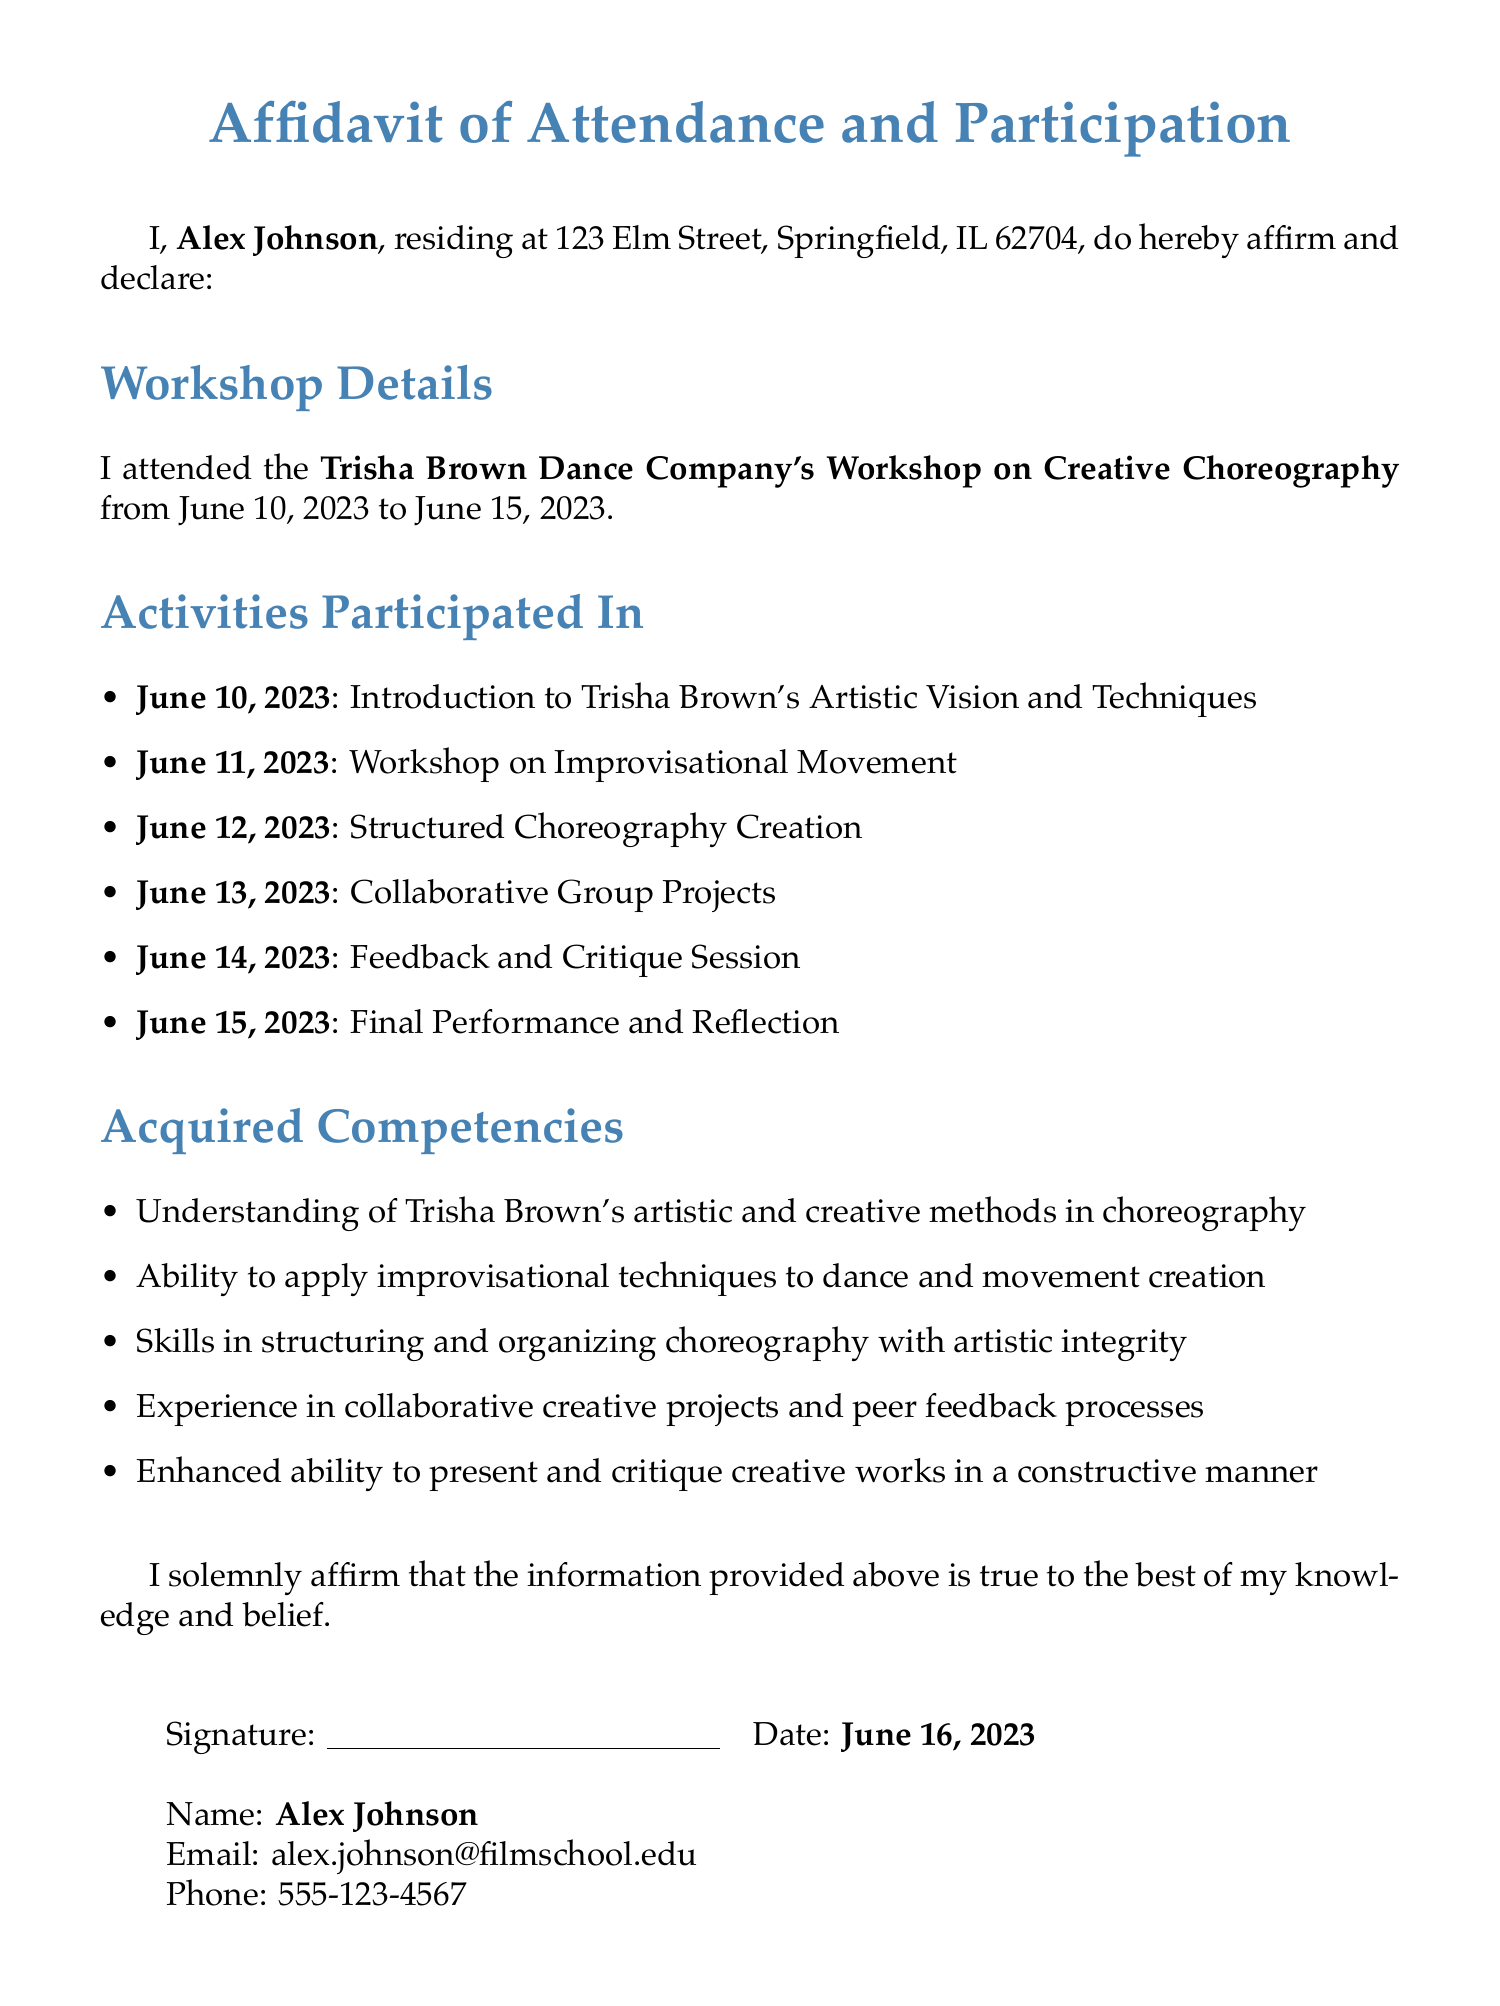What is the name of the workshop? The name of the workshop is specified in the document, highlighting Trisha Brown's affiliation and its focus on choreography.
Answer: Trisha Brown Dance Company's Workshop on Creative Choreography Who is the signer of the affidavit? The document clearly states the person's name at the beginning of the affirmation section for identification purposes.
Answer: Alex Johnson What are the dates of the workshop? The document lists the starting and ending dates of the workshop, providing a complete timeframe for the activities.
Answer: June 10, 2023 to June 15, 2023 How many activities were participated in? The activities section lists six specific dates and corresponding activities, indicating how many events were held during the workshop.
Answer: 6 What was the focus on June 11, 2023? The document specifies what activity was conducted on each day, indicating the theme of that particular day and its related learning outcome.
Answer: Workshop on Improvisational Movement What competency relates to presenting creative works? The acquired competencies section details the skills gained during the workshop, which includes the ability to present and critique in a specific manner.
Answer: Enhanced ability to present and critique creative works What type of session was held on June 14, 2023? The activities section describes the nature of the session on that specific day, emphasizing its purpose for participant development.
Answer: Feedback and Critique Session What is the email address of the signer? The document provides personal contact information, including the email address for further communication or verification.
Answer: alex.johnson@filmschool.edu 